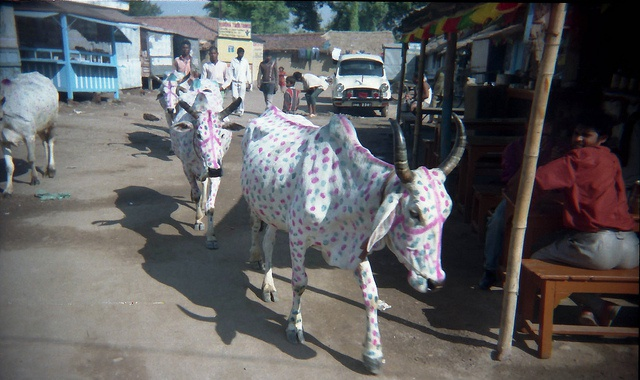Describe the objects in this image and their specific colors. I can see cow in black, gray, lightgray, and darkgray tones, people in black, maroon, and gray tones, bench in black, maroon, and gray tones, cow in black, gray, lightgray, and darkgray tones, and cow in black, darkgray, gray, lightblue, and lightgray tones in this image. 